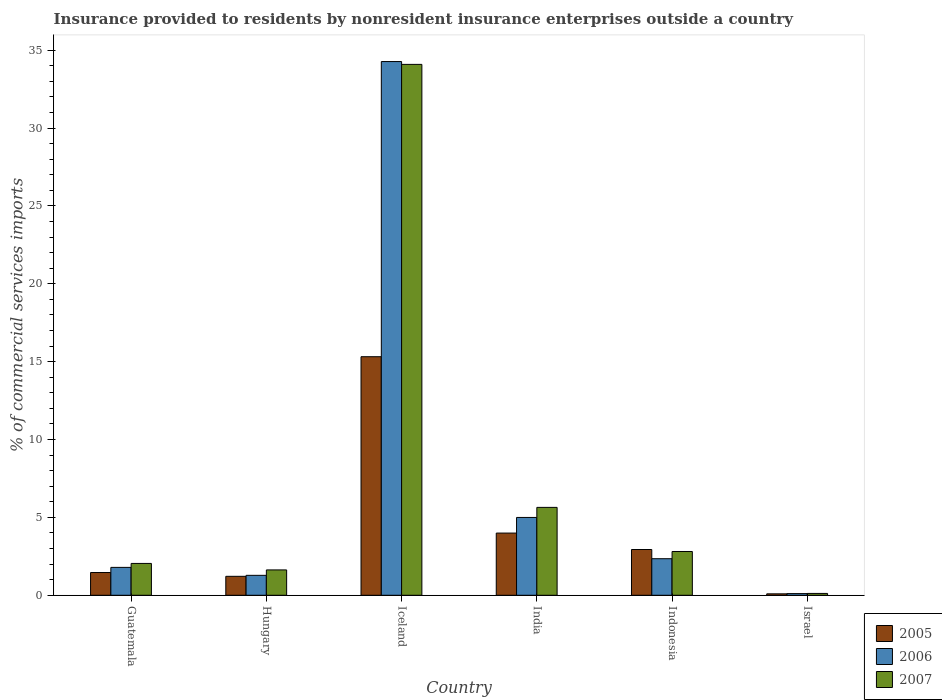How many bars are there on the 2nd tick from the right?
Provide a short and direct response. 3. In how many cases, is the number of bars for a given country not equal to the number of legend labels?
Offer a terse response. 0. What is the Insurance provided to residents in 2005 in India?
Your answer should be compact. 3.99. Across all countries, what is the maximum Insurance provided to residents in 2005?
Ensure brevity in your answer.  15.32. Across all countries, what is the minimum Insurance provided to residents in 2006?
Give a very brief answer. 0.11. In which country was the Insurance provided to residents in 2005 maximum?
Your response must be concise. Iceland. What is the total Insurance provided to residents in 2007 in the graph?
Give a very brief answer. 46.33. What is the difference between the Insurance provided to residents in 2006 in Iceland and that in Indonesia?
Give a very brief answer. 31.92. What is the difference between the Insurance provided to residents in 2006 in Indonesia and the Insurance provided to residents in 2007 in Israel?
Make the answer very short. 2.23. What is the average Insurance provided to residents in 2006 per country?
Your answer should be very brief. 7.47. What is the difference between the Insurance provided to residents of/in 2006 and Insurance provided to residents of/in 2007 in Indonesia?
Keep it short and to the point. -0.46. In how many countries, is the Insurance provided to residents in 2005 greater than 13 %?
Give a very brief answer. 1. What is the ratio of the Insurance provided to residents in 2006 in Hungary to that in Indonesia?
Make the answer very short. 0.55. Is the Insurance provided to residents in 2007 in Indonesia less than that in Israel?
Your response must be concise. No. Is the difference between the Insurance provided to residents in 2006 in Iceland and India greater than the difference between the Insurance provided to residents in 2007 in Iceland and India?
Your answer should be compact. Yes. What is the difference between the highest and the second highest Insurance provided to residents in 2005?
Keep it short and to the point. -1.06. What is the difference between the highest and the lowest Insurance provided to residents in 2005?
Ensure brevity in your answer.  15.23. In how many countries, is the Insurance provided to residents in 2006 greater than the average Insurance provided to residents in 2006 taken over all countries?
Your answer should be compact. 1. Is the sum of the Insurance provided to residents in 2006 in Guatemala and Indonesia greater than the maximum Insurance provided to residents in 2005 across all countries?
Keep it short and to the point. No. How many countries are there in the graph?
Your response must be concise. 6. Are the values on the major ticks of Y-axis written in scientific E-notation?
Ensure brevity in your answer.  No. Does the graph contain grids?
Your answer should be very brief. No. Where does the legend appear in the graph?
Offer a terse response. Bottom right. How many legend labels are there?
Offer a very short reply. 3. What is the title of the graph?
Keep it short and to the point. Insurance provided to residents by nonresident insurance enterprises outside a country. What is the label or title of the Y-axis?
Your answer should be very brief. % of commercial services imports. What is the % of commercial services imports of 2005 in Guatemala?
Provide a short and direct response. 1.46. What is the % of commercial services imports of 2006 in Guatemala?
Offer a terse response. 1.79. What is the % of commercial services imports of 2007 in Guatemala?
Provide a succinct answer. 2.04. What is the % of commercial services imports of 2005 in Hungary?
Your response must be concise. 1.22. What is the % of commercial services imports of 2006 in Hungary?
Your response must be concise. 1.28. What is the % of commercial services imports in 2007 in Hungary?
Provide a short and direct response. 1.63. What is the % of commercial services imports in 2005 in Iceland?
Provide a short and direct response. 15.32. What is the % of commercial services imports of 2006 in Iceland?
Your response must be concise. 34.27. What is the % of commercial services imports of 2007 in Iceland?
Offer a terse response. 34.09. What is the % of commercial services imports in 2005 in India?
Provide a succinct answer. 3.99. What is the % of commercial services imports in 2006 in India?
Your answer should be very brief. 5. What is the % of commercial services imports of 2007 in India?
Your answer should be very brief. 5.64. What is the % of commercial services imports of 2005 in Indonesia?
Offer a terse response. 2.94. What is the % of commercial services imports in 2006 in Indonesia?
Provide a succinct answer. 2.35. What is the % of commercial services imports of 2007 in Indonesia?
Your response must be concise. 2.81. What is the % of commercial services imports of 2005 in Israel?
Keep it short and to the point. 0.09. What is the % of commercial services imports of 2006 in Israel?
Your answer should be compact. 0.11. What is the % of commercial services imports of 2007 in Israel?
Your answer should be compact. 0.12. Across all countries, what is the maximum % of commercial services imports of 2005?
Offer a terse response. 15.32. Across all countries, what is the maximum % of commercial services imports of 2006?
Provide a short and direct response. 34.27. Across all countries, what is the maximum % of commercial services imports in 2007?
Make the answer very short. 34.09. Across all countries, what is the minimum % of commercial services imports in 2005?
Offer a very short reply. 0.09. Across all countries, what is the minimum % of commercial services imports of 2006?
Make the answer very short. 0.11. Across all countries, what is the minimum % of commercial services imports of 2007?
Your answer should be compact. 0.12. What is the total % of commercial services imports in 2005 in the graph?
Offer a terse response. 25.02. What is the total % of commercial services imports in 2006 in the graph?
Give a very brief answer. 44.79. What is the total % of commercial services imports of 2007 in the graph?
Make the answer very short. 46.33. What is the difference between the % of commercial services imports of 2005 in Guatemala and that in Hungary?
Your answer should be compact. 0.24. What is the difference between the % of commercial services imports of 2006 in Guatemala and that in Hungary?
Your response must be concise. 0.51. What is the difference between the % of commercial services imports of 2007 in Guatemala and that in Hungary?
Offer a very short reply. 0.42. What is the difference between the % of commercial services imports of 2005 in Guatemala and that in Iceland?
Offer a terse response. -13.86. What is the difference between the % of commercial services imports in 2006 in Guatemala and that in Iceland?
Provide a succinct answer. -32.48. What is the difference between the % of commercial services imports of 2007 in Guatemala and that in Iceland?
Your response must be concise. -32.04. What is the difference between the % of commercial services imports in 2005 in Guatemala and that in India?
Your response must be concise. -2.53. What is the difference between the % of commercial services imports in 2006 in Guatemala and that in India?
Ensure brevity in your answer.  -3.21. What is the difference between the % of commercial services imports in 2007 in Guatemala and that in India?
Provide a short and direct response. -3.6. What is the difference between the % of commercial services imports in 2005 in Guatemala and that in Indonesia?
Your response must be concise. -1.48. What is the difference between the % of commercial services imports of 2006 in Guatemala and that in Indonesia?
Your answer should be very brief. -0.56. What is the difference between the % of commercial services imports of 2007 in Guatemala and that in Indonesia?
Your response must be concise. -0.77. What is the difference between the % of commercial services imports in 2005 in Guatemala and that in Israel?
Ensure brevity in your answer.  1.37. What is the difference between the % of commercial services imports in 2006 in Guatemala and that in Israel?
Provide a short and direct response. 1.68. What is the difference between the % of commercial services imports of 2007 in Guatemala and that in Israel?
Your answer should be very brief. 1.93. What is the difference between the % of commercial services imports in 2005 in Hungary and that in Iceland?
Offer a terse response. -14.1. What is the difference between the % of commercial services imports of 2006 in Hungary and that in Iceland?
Ensure brevity in your answer.  -32.99. What is the difference between the % of commercial services imports of 2007 in Hungary and that in Iceland?
Provide a succinct answer. -32.46. What is the difference between the % of commercial services imports in 2005 in Hungary and that in India?
Offer a terse response. -2.78. What is the difference between the % of commercial services imports of 2006 in Hungary and that in India?
Provide a succinct answer. -3.72. What is the difference between the % of commercial services imports of 2007 in Hungary and that in India?
Provide a succinct answer. -4.02. What is the difference between the % of commercial services imports in 2005 in Hungary and that in Indonesia?
Provide a short and direct response. -1.72. What is the difference between the % of commercial services imports of 2006 in Hungary and that in Indonesia?
Your answer should be very brief. -1.07. What is the difference between the % of commercial services imports in 2007 in Hungary and that in Indonesia?
Give a very brief answer. -1.18. What is the difference between the % of commercial services imports of 2005 in Hungary and that in Israel?
Give a very brief answer. 1.13. What is the difference between the % of commercial services imports of 2006 in Hungary and that in Israel?
Keep it short and to the point. 1.17. What is the difference between the % of commercial services imports in 2007 in Hungary and that in Israel?
Your answer should be very brief. 1.51. What is the difference between the % of commercial services imports in 2005 in Iceland and that in India?
Give a very brief answer. 11.32. What is the difference between the % of commercial services imports of 2006 in Iceland and that in India?
Offer a very short reply. 29.27. What is the difference between the % of commercial services imports of 2007 in Iceland and that in India?
Make the answer very short. 28.45. What is the difference between the % of commercial services imports of 2005 in Iceland and that in Indonesia?
Give a very brief answer. 12.38. What is the difference between the % of commercial services imports in 2006 in Iceland and that in Indonesia?
Keep it short and to the point. 31.92. What is the difference between the % of commercial services imports in 2007 in Iceland and that in Indonesia?
Offer a very short reply. 31.28. What is the difference between the % of commercial services imports of 2005 in Iceland and that in Israel?
Your answer should be compact. 15.23. What is the difference between the % of commercial services imports of 2006 in Iceland and that in Israel?
Offer a very short reply. 34.16. What is the difference between the % of commercial services imports in 2007 in Iceland and that in Israel?
Make the answer very short. 33.97. What is the difference between the % of commercial services imports of 2005 in India and that in Indonesia?
Ensure brevity in your answer.  1.06. What is the difference between the % of commercial services imports in 2006 in India and that in Indonesia?
Provide a short and direct response. 2.65. What is the difference between the % of commercial services imports of 2007 in India and that in Indonesia?
Offer a very short reply. 2.83. What is the difference between the % of commercial services imports in 2005 in India and that in Israel?
Offer a very short reply. 3.9. What is the difference between the % of commercial services imports of 2006 in India and that in Israel?
Make the answer very short. 4.89. What is the difference between the % of commercial services imports in 2007 in India and that in Israel?
Offer a very short reply. 5.53. What is the difference between the % of commercial services imports in 2005 in Indonesia and that in Israel?
Your response must be concise. 2.85. What is the difference between the % of commercial services imports in 2006 in Indonesia and that in Israel?
Offer a terse response. 2.24. What is the difference between the % of commercial services imports of 2007 in Indonesia and that in Israel?
Offer a very short reply. 2.69. What is the difference between the % of commercial services imports in 2005 in Guatemala and the % of commercial services imports in 2006 in Hungary?
Provide a short and direct response. 0.18. What is the difference between the % of commercial services imports in 2005 in Guatemala and the % of commercial services imports in 2007 in Hungary?
Give a very brief answer. -0.17. What is the difference between the % of commercial services imports in 2006 in Guatemala and the % of commercial services imports in 2007 in Hungary?
Keep it short and to the point. 0.16. What is the difference between the % of commercial services imports in 2005 in Guatemala and the % of commercial services imports in 2006 in Iceland?
Provide a short and direct response. -32.81. What is the difference between the % of commercial services imports in 2005 in Guatemala and the % of commercial services imports in 2007 in Iceland?
Offer a terse response. -32.63. What is the difference between the % of commercial services imports of 2006 in Guatemala and the % of commercial services imports of 2007 in Iceland?
Your answer should be compact. -32.3. What is the difference between the % of commercial services imports in 2005 in Guatemala and the % of commercial services imports in 2006 in India?
Keep it short and to the point. -3.54. What is the difference between the % of commercial services imports in 2005 in Guatemala and the % of commercial services imports in 2007 in India?
Ensure brevity in your answer.  -4.18. What is the difference between the % of commercial services imports in 2006 in Guatemala and the % of commercial services imports in 2007 in India?
Provide a short and direct response. -3.85. What is the difference between the % of commercial services imports of 2005 in Guatemala and the % of commercial services imports of 2006 in Indonesia?
Ensure brevity in your answer.  -0.89. What is the difference between the % of commercial services imports in 2005 in Guatemala and the % of commercial services imports in 2007 in Indonesia?
Your answer should be compact. -1.35. What is the difference between the % of commercial services imports in 2006 in Guatemala and the % of commercial services imports in 2007 in Indonesia?
Give a very brief answer. -1.02. What is the difference between the % of commercial services imports of 2005 in Guatemala and the % of commercial services imports of 2006 in Israel?
Your response must be concise. 1.35. What is the difference between the % of commercial services imports in 2005 in Guatemala and the % of commercial services imports in 2007 in Israel?
Your answer should be very brief. 1.34. What is the difference between the % of commercial services imports of 2006 in Guatemala and the % of commercial services imports of 2007 in Israel?
Your answer should be very brief. 1.67. What is the difference between the % of commercial services imports in 2005 in Hungary and the % of commercial services imports in 2006 in Iceland?
Ensure brevity in your answer.  -33.05. What is the difference between the % of commercial services imports of 2005 in Hungary and the % of commercial services imports of 2007 in Iceland?
Keep it short and to the point. -32.87. What is the difference between the % of commercial services imports in 2006 in Hungary and the % of commercial services imports in 2007 in Iceland?
Provide a succinct answer. -32.81. What is the difference between the % of commercial services imports in 2005 in Hungary and the % of commercial services imports in 2006 in India?
Offer a terse response. -3.78. What is the difference between the % of commercial services imports of 2005 in Hungary and the % of commercial services imports of 2007 in India?
Provide a succinct answer. -4.43. What is the difference between the % of commercial services imports of 2006 in Hungary and the % of commercial services imports of 2007 in India?
Your answer should be compact. -4.36. What is the difference between the % of commercial services imports in 2005 in Hungary and the % of commercial services imports in 2006 in Indonesia?
Your answer should be very brief. -1.13. What is the difference between the % of commercial services imports of 2005 in Hungary and the % of commercial services imports of 2007 in Indonesia?
Your answer should be very brief. -1.59. What is the difference between the % of commercial services imports in 2006 in Hungary and the % of commercial services imports in 2007 in Indonesia?
Provide a short and direct response. -1.53. What is the difference between the % of commercial services imports in 2005 in Hungary and the % of commercial services imports in 2006 in Israel?
Your answer should be compact. 1.11. What is the difference between the % of commercial services imports of 2005 in Hungary and the % of commercial services imports of 2007 in Israel?
Provide a short and direct response. 1.1. What is the difference between the % of commercial services imports in 2006 in Hungary and the % of commercial services imports in 2007 in Israel?
Give a very brief answer. 1.16. What is the difference between the % of commercial services imports in 2005 in Iceland and the % of commercial services imports in 2006 in India?
Keep it short and to the point. 10.32. What is the difference between the % of commercial services imports of 2005 in Iceland and the % of commercial services imports of 2007 in India?
Make the answer very short. 9.68. What is the difference between the % of commercial services imports in 2006 in Iceland and the % of commercial services imports in 2007 in India?
Give a very brief answer. 28.63. What is the difference between the % of commercial services imports of 2005 in Iceland and the % of commercial services imports of 2006 in Indonesia?
Give a very brief answer. 12.97. What is the difference between the % of commercial services imports in 2005 in Iceland and the % of commercial services imports in 2007 in Indonesia?
Give a very brief answer. 12.51. What is the difference between the % of commercial services imports of 2006 in Iceland and the % of commercial services imports of 2007 in Indonesia?
Make the answer very short. 31.46. What is the difference between the % of commercial services imports of 2005 in Iceland and the % of commercial services imports of 2006 in Israel?
Provide a succinct answer. 15.21. What is the difference between the % of commercial services imports of 2005 in Iceland and the % of commercial services imports of 2007 in Israel?
Provide a short and direct response. 15.2. What is the difference between the % of commercial services imports of 2006 in Iceland and the % of commercial services imports of 2007 in Israel?
Your answer should be compact. 34.15. What is the difference between the % of commercial services imports in 2005 in India and the % of commercial services imports in 2006 in Indonesia?
Make the answer very short. 1.65. What is the difference between the % of commercial services imports of 2005 in India and the % of commercial services imports of 2007 in Indonesia?
Ensure brevity in your answer.  1.18. What is the difference between the % of commercial services imports in 2006 in India and the % of commercial services imports in 2007 in Indonesia?
Offer a terse response. 2.19. What is the difference between the % of commercial services imports of 2005 in India and the % of commercial services imports of 2006 in Israel?
Your response must be concise. 3.89. What is the difference between the % of commercial services imports in 2005 in India and the % of commercial services imports in 2007 in Israel?
Your answer should be very brief. 3.88. What is the difference between the % of commercial services imports of 2006 in India and the % of commercial services imports of 2007 in Israel?
Your response must be concise. 4.88. What is the difference between the % of commercial services imports in 2005 in Indonesia and the % of commercial services imports in 2006 in Israel?
Make the answer very short. 2.83. What is the difference between the % of commercial services imports of 2005 in Indonesia and the % of commercial services imports of 2007 in Israel?
Provide a succinct answer. 2.82. What is the difference between the % of commercial services imports in 2006 in Indonesia and the % of commercial services imports in 2007 in Israel?
Provide a short and direct response. 2.23. What is the average % of commercial services imports in 2005 per country?
Provide a succinct answer. 4.17. What is the average % of commercial services imports in 2006 per country?
Your answer should be very brief. 7.47. What is the average % of commercial services imports in 2007 per country?
Offer a very short reply. 7.72. What is the difference between the % of commercial services imports of 2005 and % of commercial services imports of 2006 in Guatemala?
Offer a very short reply. -0.33. What is the difference between the % of commercial services imports of 2005 and % of commercial services imports of 2007 in Guatemala?
Provide a succinct answer. -0.58. What is the difference between the % of commercial services imports in 2006 and % of commercial services imports in 2007 in Guatemala?
Offer a very short reply. -0.25. What is the difference between the % of commercial services imports in 2005 and % of commercial services imports in 2006 in Hungary?
Give a very brief answer. -0.06. What is the difference between the % of commercial services imports of 2005 and % of commercial services imports of 2007 in Hungary?
Your answer should be very brief. -0.41. What is the difference between the % of commercial services imports of 2006 and % of commercial services imports of 2007 in Hungary?
Provide a succinct answer. -0.35. What is the difference between the % of commercial services imports in 2005 and % of commercial services imports in 2006 in Iceland?
Your response must be concise. -18.95. What is the difference between the % of commercial services imports in 2005 and % of commercial services imports in 2007 in Iceland?
Give a very brief answer. -18.77. What is the difference between the % of commercial services imports of 2006 and % of commercial services imports of 2007 in Iceland?
Keep it short and to the point. 0.18. What is the difference between the % of commercial services imports of 2005 and % of commercial services imports of 2006 in India?
Your answer should be very brief. -1. What is the difference between the % of commercial services imports in 2005 and % of commercial services imports in 2007 in India?
Give a very brief answer. -1.65. What is the difference between the % of commercial services imports in 2006 and % of commercial services imports in 2007 in India?
Your answer should be very brief. -0.65. What is the difference between the % of commercial services imports in 2005 and % of commercial services imports in 2006 in Indonesia?
Ensure brevity in your answer.  0.59. What is the difference between the % of commercial services imports of 2005 and % of commercial services imports of 2007 in Indonesia?
Offer a terse response. 0.13. What is the difference between the % of commercial services imports of 2006 and % of commercial services imports of 2007 in Indonesia?
Keep it short and to the point. -0.46. What is the difference between the % of commercial services imports of 2005 and % of commercial services imports of 2006 in Israel?
Your answer should be compact. -0.02. What is the difference between the % of commercial services imports in 2005 and % of commercial services imports in 2007 in Israel?
Your answer should be compact. -0.03. What is the difference between the % of commercial services imports of 2006 and % of commercial services imports of 2007 in Israel?
Offer a terse response. -0.01. What is the ratio of the % of commercial services imports of 2005 in Guatemala to that in Hungary?
Your answer should be very brief. 1.2. What is the ratio of the % of commercial services imports in 2006 in Guatemala to that in Hungary?
Keep it short and to the point. 1.4. What is the ratio of the % of commercial services imports in 2007 in Guatemala to that in Hungary?
Offer a terse response. 1.26. What is the ratio of the % of commercial services imports in 2005 in Guatemala to that in Iceland?
Offer a terse response. 0.1. What is the ratio of the % of commercial services imports of 2006 in Guatemala to that in Iceland?
Offer a very short reply. 0.05. What is the ratio of the % of commercial services imports in 2007 in Guatemala to that in Iceland?
Ensure brevity in your answer.  0.06. What is the ratio of the % of commercial services imports in 2005 in Guatemala to that in India?
Offer a very short reply. 0.37. What is the ratio of the % of commercial services imports in 2006 in Guatemala to that in India?
Offer a very short reply. 0.36. What is the ratio of the % of commercial services imports in 2007 in Guatemala to that in India?
Ensure brevity in your answer.  0.36. What is the ratio of the % of commercial services imports in 2005 in Guatemala to that in Indonesia?
Ensure brevity in your answer.  0.5. What is the ratio of the % of commercial services imports of 2006 in Guatemala to that in Indonesia?
Offer a very short reply. 0.76. What is the ratio of the % of commercial services imports of 2007 in Guatemala to that in Indonesia?
Offer a terse response. 0.73. What is the ratio of the % of commercial services imports of 2005 in Guatemala to that in Israel?
Provide a succinct answer. 15.9. What is the ratio of the % of commercial services imports in 2006 in Guatemala to that in Israel?
Provide a succinct answer. 16.65. What is the ratio of the % of commercial services imports of 2007 in Guatemala to that in Israel?
Give a very brief answer. 17.3. What is the ratio of the % of commercial services imports of 2005 in Hungary to that in Iceland?
Give a very brief answer. 0.08. What is the ratio of the % of commercial services imports of 2006 in Hungary to that in Iceland?
Offer a very short reply. 0.04. What is the ratio of the % of commercial services imports of 2007 in Hungary to that in Iceland?
Your answer should be very brief. 0.05. What is the ratio of the % of commercial services imports of 2005 in Hungary to that in India?
Your answer should be compact. 0.3. What is the ratio of the % of commercial services imports of 2006 in Hungary to that in India?
Provide a succinct answer. 0.26. What is the ratio of the % of commercial services imports of 2007 in Hungary to that in India?
Your answer should be compact. 0.29. What is the ratio of the % of commercial services imports of 2005 in Hungary to that in Indonesia?
Provide a succinct answer. 0.41. What is the ratio of the % of commercial services imports of 2006 in Hungary to that in Indonesia?
Ensure brevity in your answer.  0.55. What is the ratio of the % of commercial services imports in 2007 in Hungary to that in Indonesia?
Provide a short and direct response. 0.58. What is the ratio of the % of commercial services imports of 2005 in Hungary to that in Israel?
Ensure brevity in your answer.  13.25. What is the ratio of the % of commercial services imports of 2006 in Hungary to that in Israel?
Keep it short and to the point. 11.9. What is the ratio of the % of commercial services imports in 2007 in Hungary to that in Israel?
Ensure brevity in your answer.  13.77. What is the ratio of the % of commercial services imports in 2005 in Iceland to that in India?
Your answer should be very brief. 3.84. What is the ratio of the % of commercial services imports of 2006 in Iceland to that in India?
Provide a short and direct response. 6.86. What is the ratio of the % of commercial services imports in 2007 in Iceland to that in India?
Your answer should be very brief. 6.04. What is the ratio of the % of commercial services imports in 2005 in Iceland to that in Indonesia?
Keep it short and to the point. 5.21. What is the ratio of the % of commercial services imports in 2006 in Iceland to that in Indonesia?
Offer a very short reply. 14.6. What is the ratio of the % of commercial services imports of 2007 in Iceland to that in Indonesia?
Your response must be concise. 12.13. What is the ratio of the % of commercial services imports of 2005 in Iceland to that in Israel?
Ensure brevity in your answer.  166.75. What is the ratio of the % of commercial services imports of 2006 in Iceland to that in Israel?
Offer a very short reply. 318.6. What is the ratio of the % of commercial services imports in 2007 in Iceland to that in Israel?
Provide a succinct answer. 288.38. What is the ratio of the % of commercial services imports of 2005 in India to that in Indonesia?
Your response must be concise. 1.36. What is the ratio of the % of commercial services imports of 2006 in India to that in Indonesia?
Offer a terse response. 2.13. What is the ratio of the % of commercial services imports of 2007 in India to that in Indonesia?
Your answer should be very brief. 2.01. What is the ratio of the % of commercial services imports in 2005 in India to that in Israel?
Ensure brevity in your answer.  43.48. What is the ratio of the % of commercial services imports of 2006 in India to that in Israel?
Provide a short and direct response. 46.46. What is the ratio of the % of commercial services imports of 2007 in India to that in Israel?
Make the answer very short. 47.74. What is the ratio of the % of commercial services imports of 2005 in Indonesia to that in Israel?
Offer a terse response. 31.99. What is the ratio of the % of commercial services imports of 2006 in Indonesia to that in Israel?
Your answer should be compact. 21.83. What is the ratio of the % of commercial services imports in 2007 in Indonesia to that in Israel?
Provide a succinct answer. 23.78. What is the difference between the highest and the second highest % of commercial services imports in 2005?
Keep it short and to the point. 11.32. What is the difference between the highest and the second highest % of commercial services imports of 2006?
Your response must be concise. 29.27. What is the difference between the highest and the second highest % of commercial services imports of 2007?
Give a very brief answer. 28.45. What is the difference between the highest and the lowest % of commercial services imports of 2005?
Provide a succinct answer. 15.23. What is the difference between the highest and the lowest % of commercial services imports of 2006?
Ensure brevity in your answer.  34.16. What is the difference between the highest and the lowest % of commercial services imports in 2007?
Make the answer very short. 33.97. 